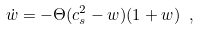<formula> <loc_0><loc_0><loc_500><loc_500>\dot { w } = - \Theta ( c _ { s } ^ { 2 } - w ) ( 1 + w ) \ ,</formula> 